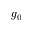Convert formula to latex. <formula><loc_0><loc_0><loc_500><loc_500>g _ { 0 }</formula> 